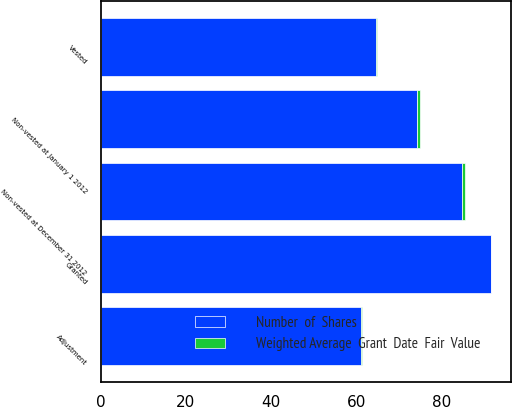Convert chart to OTSL. <chart><loc_0><loc_0><loc_500><loc_500><stacked_bar_chart><ecel><fcel>Non-vested at January 1 2012<fcel>Granted<fcel>Adjustment<fcel>Vested<fcel>Non-vested at December 31 2012<nl><fcel>Weighted Average  Grant  Date  Fair  Value<fcel>0.6<fcel>0.2<fcel>0.1<fcel>0.3<fcel>0.6<nl><fcel>Number  of  Shares<fcel>74.39<fcel>91.62<fcel>61.19<fcel>64.6<fcel>84.91<nl></chart> 